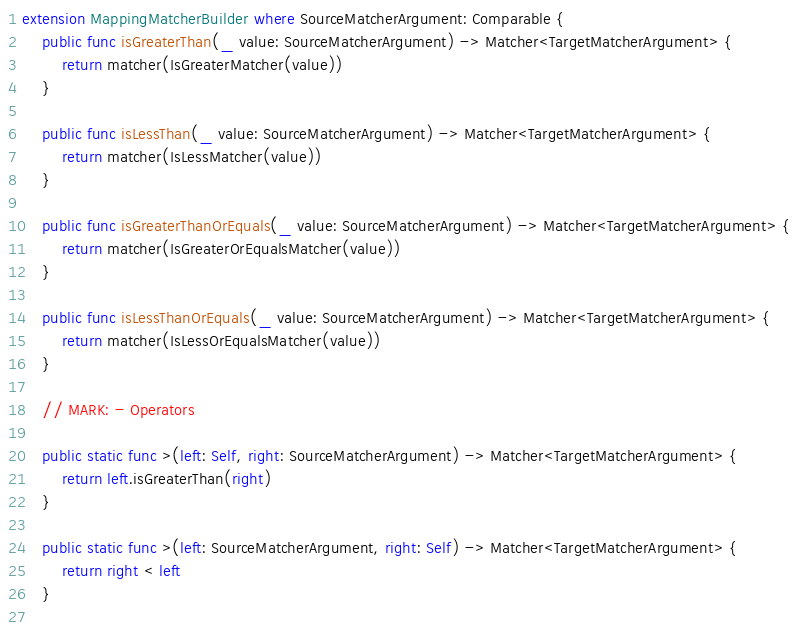Convert code to text. <code><loc_0><loc_0><loc_500><loc_500><_Swift_>extension MappingMatcherBuilder where SourceMatcherArgument: Comparable {
    public func isGreaterThan(_ value: SourceMatcherArgument) -> Matcher<TargetMatcherArgument> {
        return matcher(IsGreaterMatcher(value))
    }
    
    public func isLessThan(_ value: SourceMatcherArgument) -> Matcher<TargetMatcherArgument> {
        return matcher(IsLessMatcher(value))
    }
    
    public func isGreaterThanOrEquals(_ value: SourceMatcherArgument) -> Matcher<TargetMatcherArgument> {
        return matcher(IsGreaterOrEqualsMatcher(value))
    }
    
    public func isLessThanOrEquals(_ value: SourceMatcherArgument) -> Matcher<TargetMatcherArgument> {
        return matcher(IsLessOrEqualsMatcher(value))
    }
    
    // MARK: - Operators
    
    public static func >(left: Self, right: SourceMatcherArgument) -> Matcher<TargetMatcherArgument> {
        return left.isGreaterThan(right)
    }
    
    public static func >(left: SourceMatcherArgument, right: Self) -> Matcher<TargetMatcherArgument> {
        return right < left
    }
    </code> 